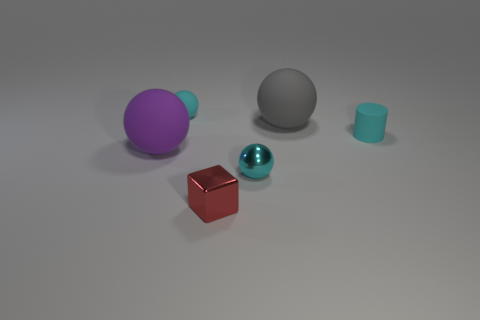Is there a big red cylinder that has the same material as the gray sphere?
Your response must be concise. No. There is a cyan matte object left of the red cube; does it have the same size as the big gray rubber object?
Ensure brevity in your answer.  No. Is there a gray matte object left of the small metal object in front of the tiny cyan sphere in front of the gray rubber sphere?
Your response must be concise. No. How many metal objects are either tiny cyan balls or small green spheres?
Your answer should be very brief. 1. How many other objects are the same shape as the gray matte thing?
Offer a very short reply. 3. Is the number of tiny cyan balls greater than the number of blocks?
Provide a succinct answer. Yes. There is a sphere that is behind the big matte sphere right of the large object left of the gray sphere; what is its size?
Your answer should be compact. Small. There is a cyan rubber thing that is to the left of the small block; what is its size?
Ensure brevity in your answer.  Small. How many things are either tiny purple metal things or tiny spheres to the left of the tiny red block?
Make the answer very short. 1. What number of other things are the same size as the shiny block?
Ensure brevity in your answer.  3. 